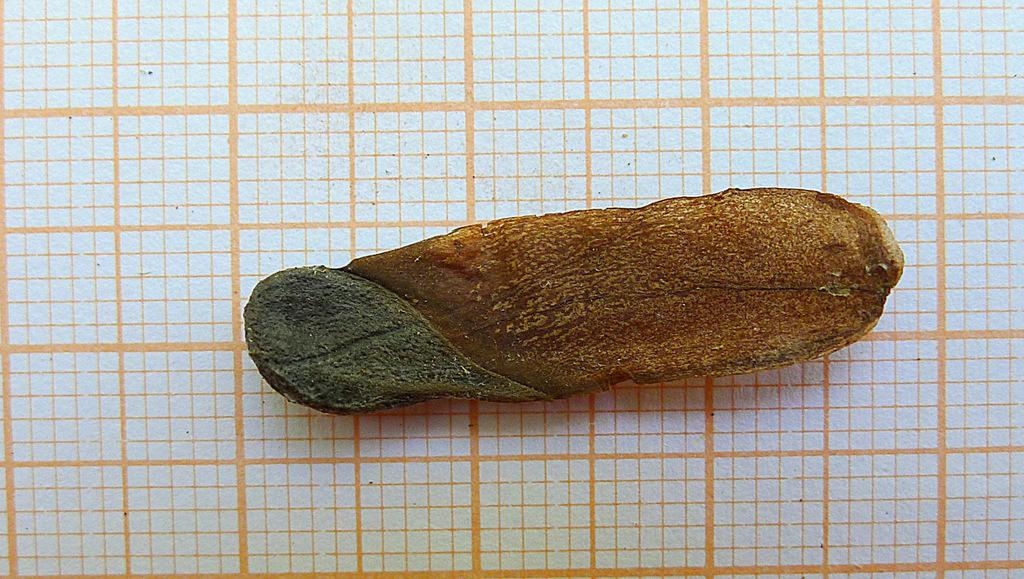What is present in the image? There is food in the image. Where is the food located? The food is placed on a surface. What type of apparatus is used to say good-bye in the image? There is no apparatus or good-bye in the image; it only features food placed on a surface. 